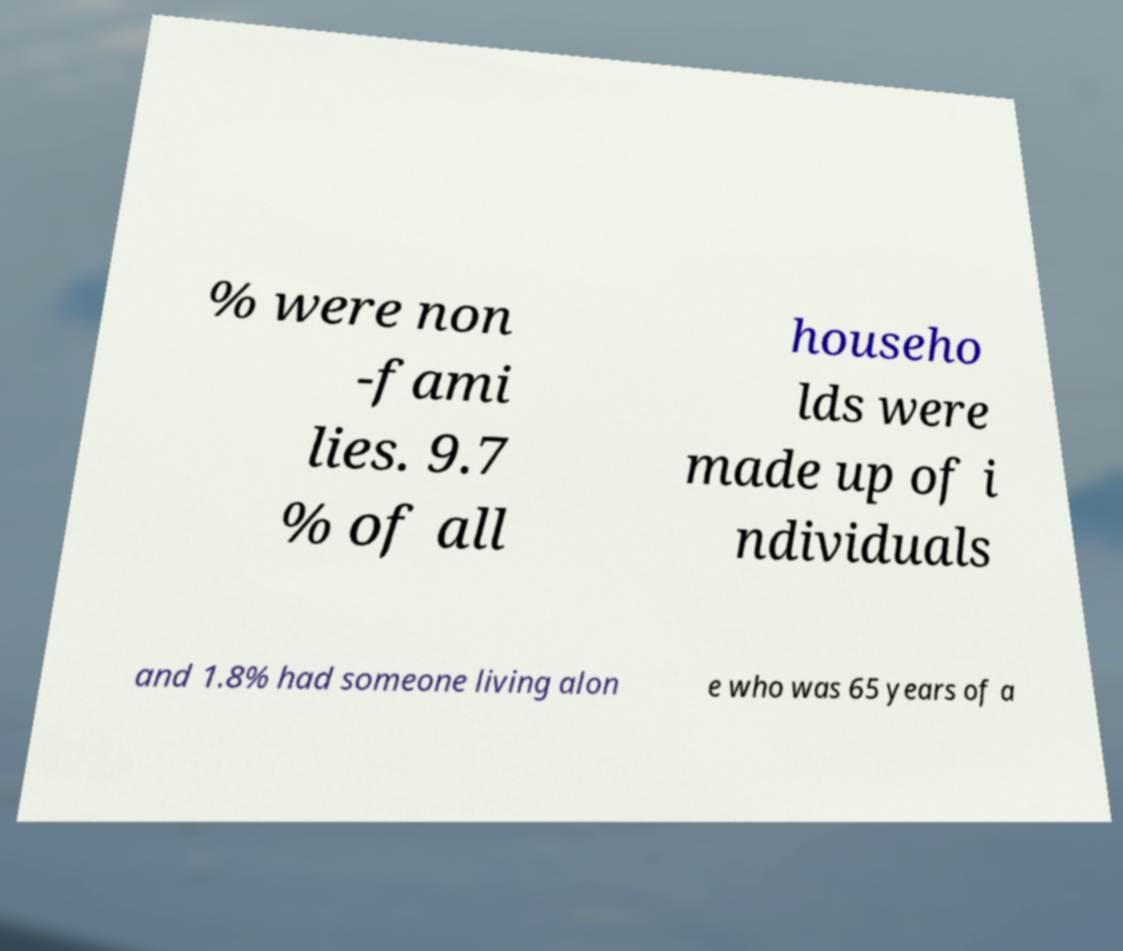Can you read and provide the text displayed in the image?This photo seems to have some interesting text. Can you extract and type it out for me? % were non -fami lies. 9.7 % of all househo lds were made up of i ndividuals and 1.8% had someone living alon e who was 65 years of a 